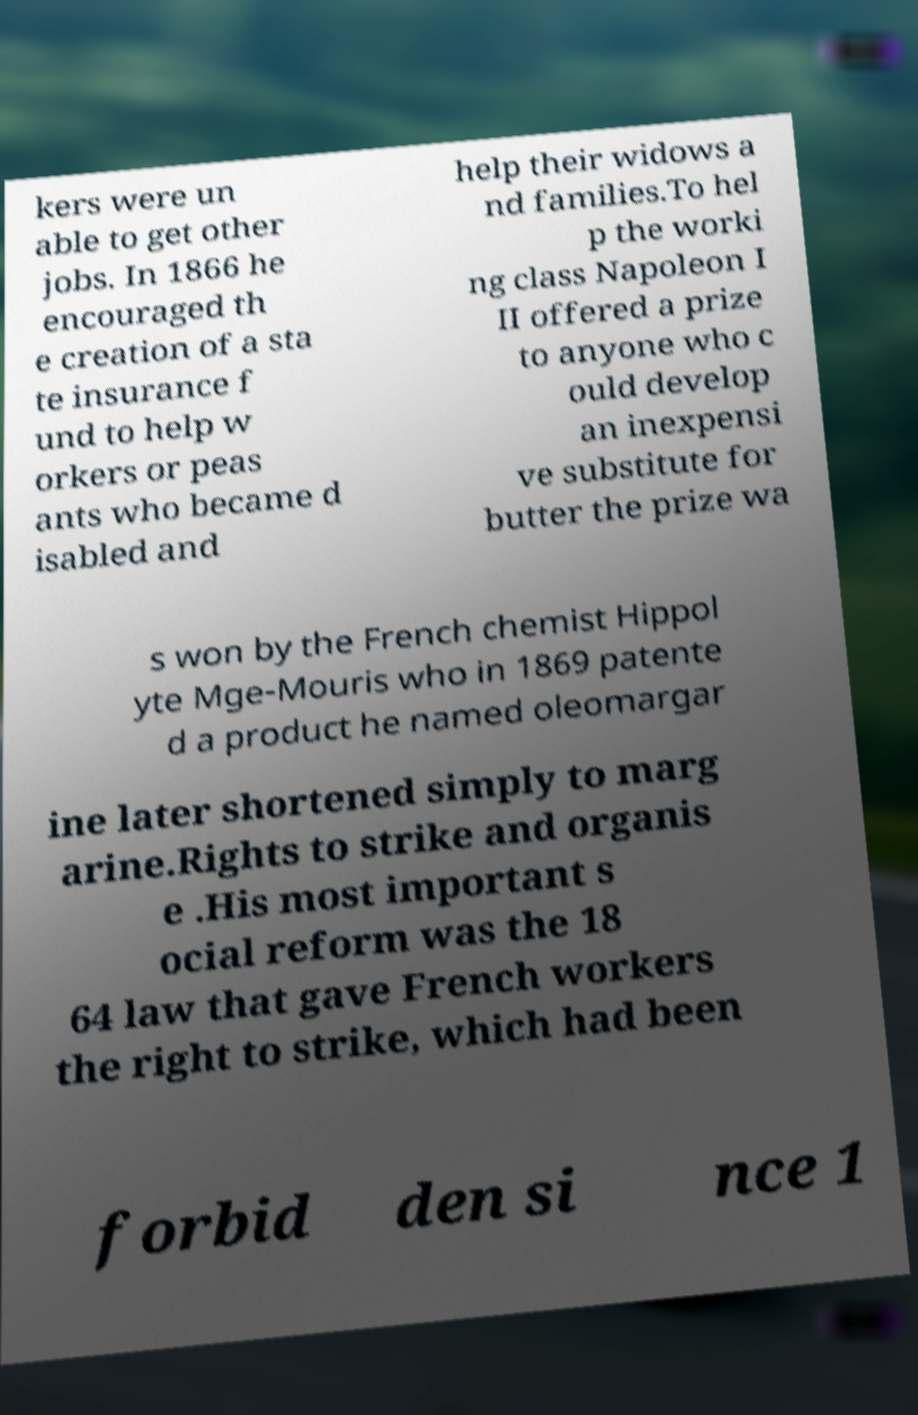I need the written content from this picture converted into text. Can you do that? kers were un able to get other jobs. In 1866 he encouraged th e creation of a sta te insurance f und to help w orkers or peas ants who became d isabled and help their widows a nd families.To hel p the worki ng class Napoleon I II offered a prize to anyone who c ould develop an inexpensi ve substitute for butter the prize wa s won by the French chemist Hippol yte Mge-Mouris who in 1869 patente d a product he named oleomargar ine later shortened simply to marg arine.Rights to strike and organis e .His most important s ocial reform was the 18 64 law that gave French workers the right to strike, which had been forbid den si nce 1 